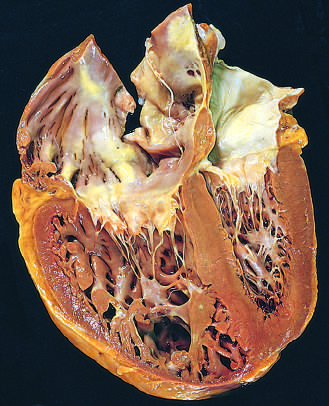what have the shape and volume of the left ventricle been distorted by?
Answer the question using a single word or phrase. The enlarged right ventricle 